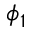Convert formula to latex. <formula><loc_0><loc_0><loc_500><loc_500>\phi _ { 1 }</formula> 